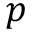<formula> <loc_0><loc_0><loc_500><loc_500>p</formula> 